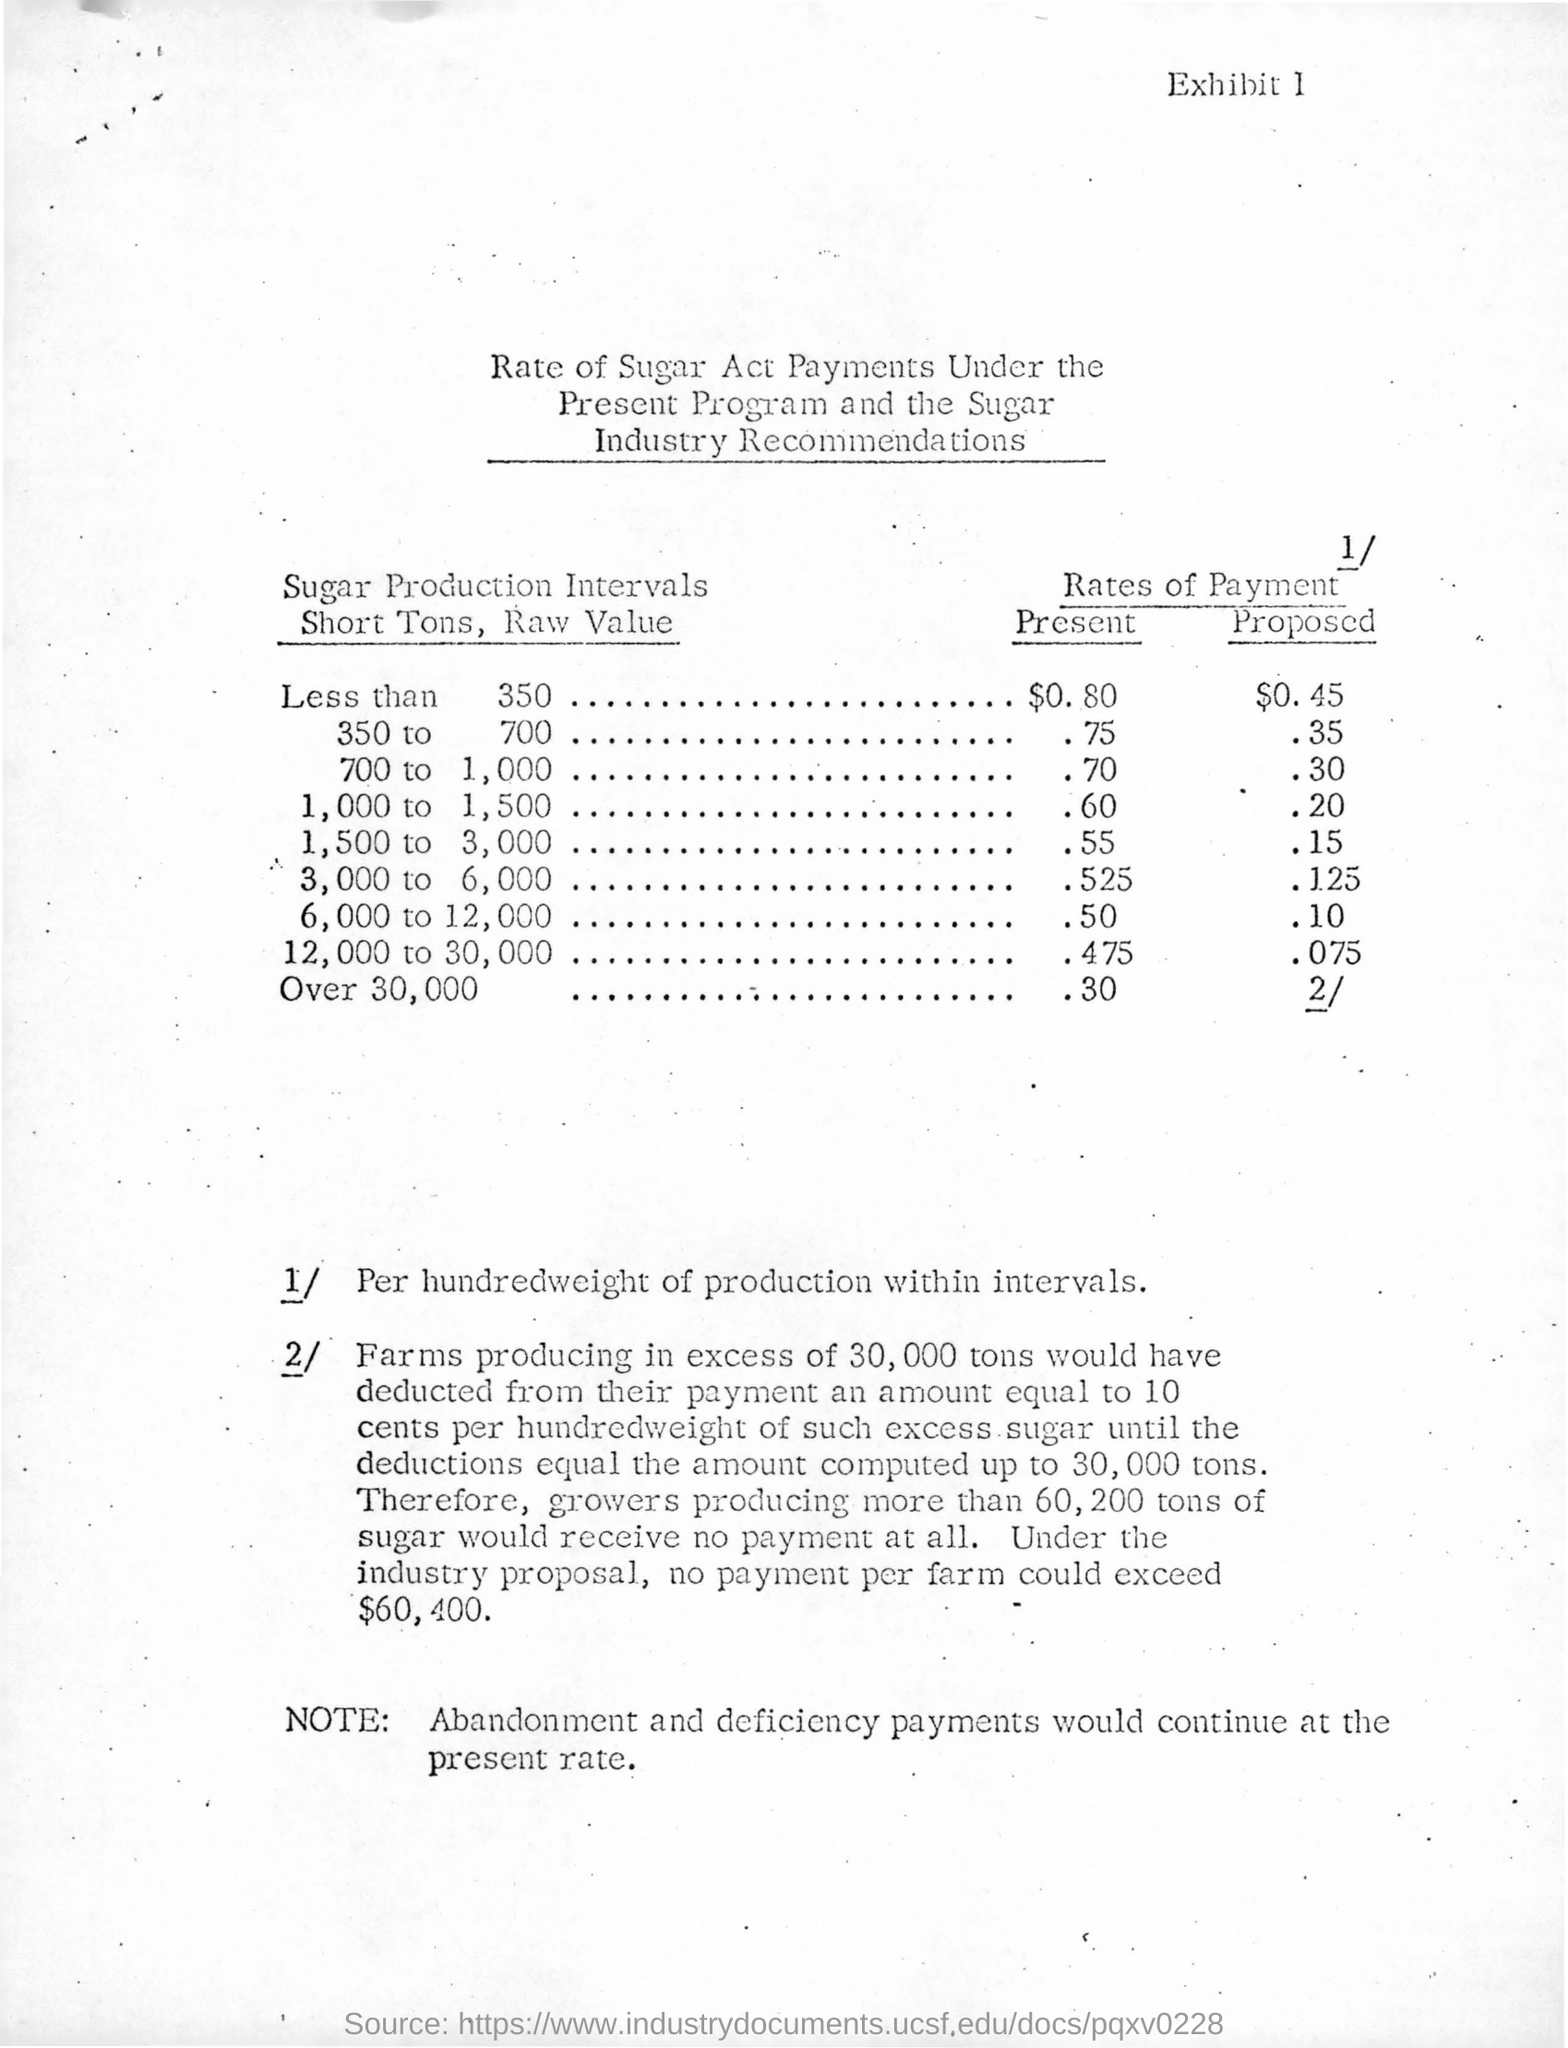What is the exhibit number?
Provide a short and direct response. 1. 